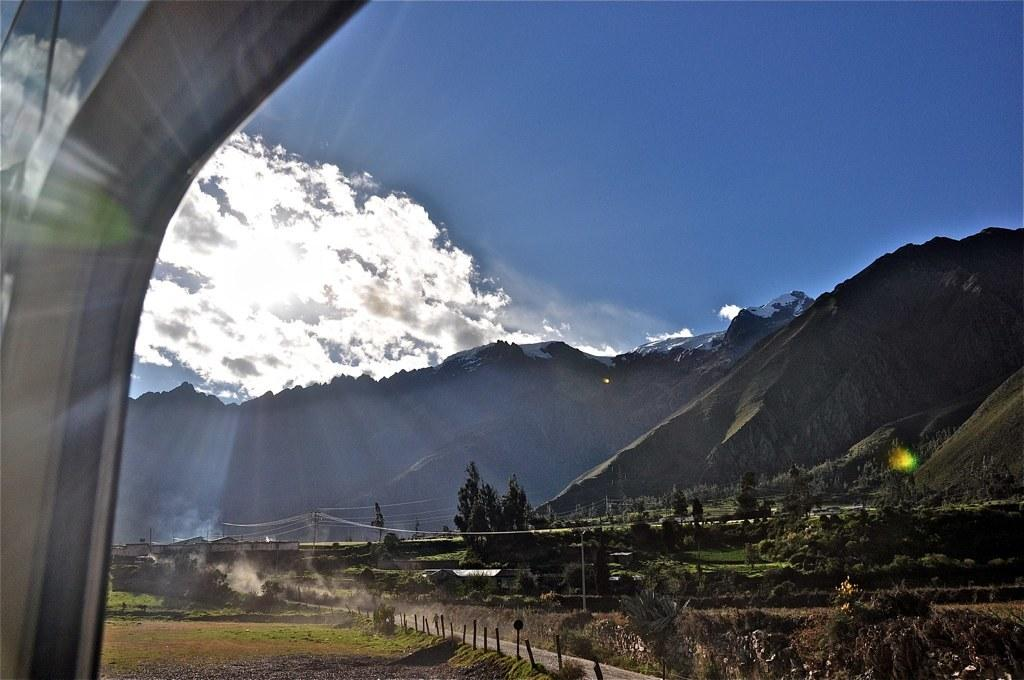What type of landscape is depicted in the image? The image features hills and trees. What structures can be seen in the image? There are poles and power line cables visible in the image. What is visible at the top of the image? The sky is visible at the top of the image. Is there a kettle boiling on the hill in the image? There is no kettle present in the image. What type of rail is visible in the image? There is no rail visible in the image. 